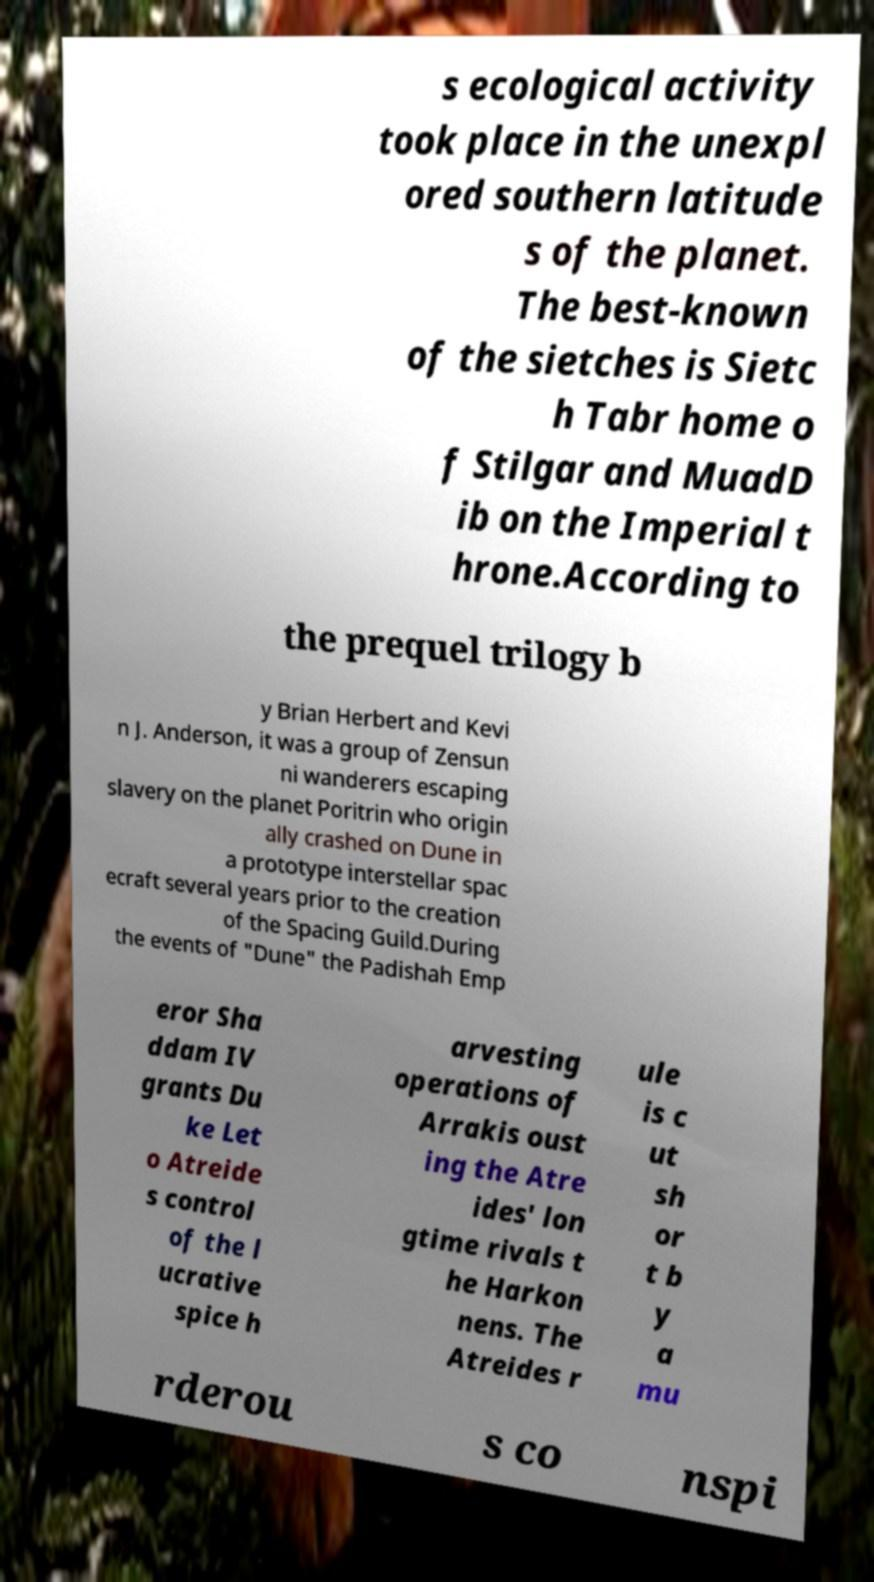Could you assist in decoding the text presented in this image and type it out clearly? s ecological activity took place in the unexpl ored southern latitude s of the planet. The best-known of the sietches is Sietc h Tabr home o f Stilgar and MuadD ib on the Imperial t hrone.According to the prequel trilogy b y Brian Herbert and Kevi n J. Anderson, it was a group of Zensun ni wanderers escaping slavery on the planet Poritrin who origin ally crashed on Dune in a prototype interstellar spac ecraft several years prior to the creation of the Spacing Guild.During the events of "Dune" the Padishah Emp eror Sha ddam IV grants Du ke Let o Atreide s control of the l ucrative spice h arvesting operations of Arrakis oust ing the Atre ides' lon gtime rivals t he Harkon nens. The Atreides r ule is c ut sh or t b y a mu rderou s co nspi 